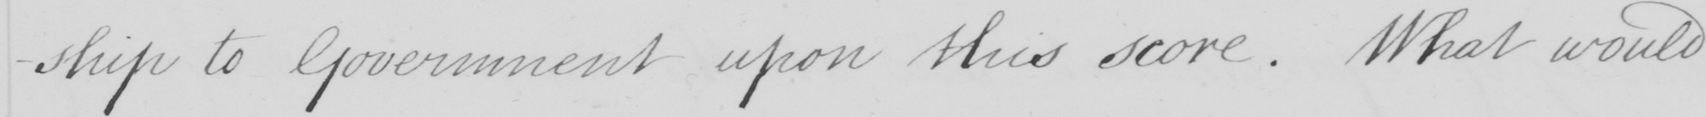Can you tell me what this handwritten text says? -ship to Government upon this score . What would 